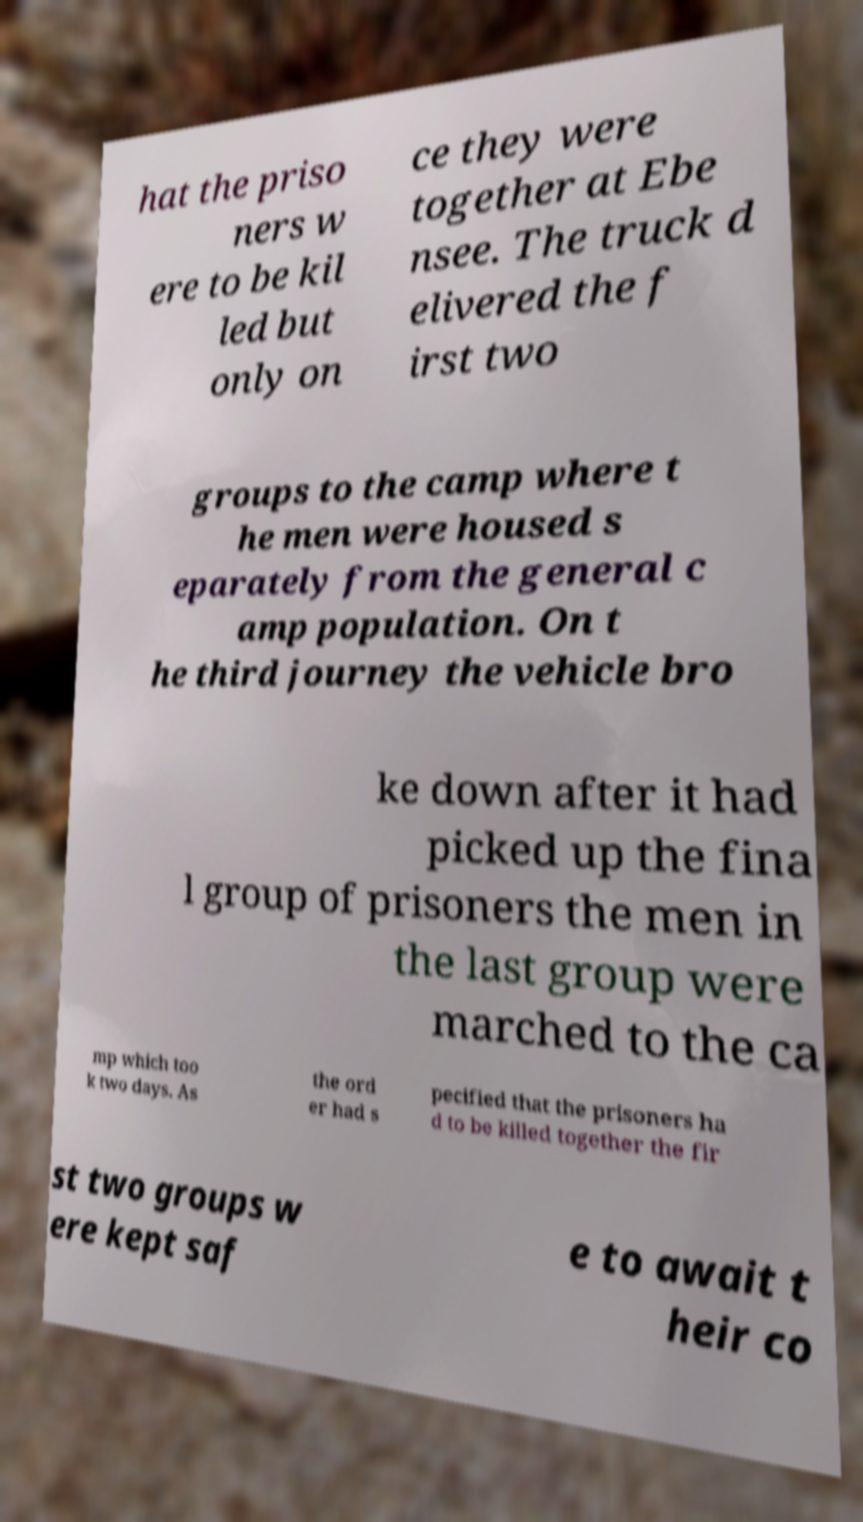What messages or text are displayed in this image? I need them in a readable, typed format. hat the priso ners w ere to be kil led but only on ce they were together at Ebe nsee. The truck d elivered the f irst two groups to the camp where t he men were housed s eparately from the general c amp population. On t he third journey the vehicle bro ke down after it had picked up the fina l group of prisoners the men in the last group were marched to the ca mp which too k two days. As the ord er had s pecified that the prisoners ha d to be killed together the fir st two groups w ere kept saf e to await t heir co 